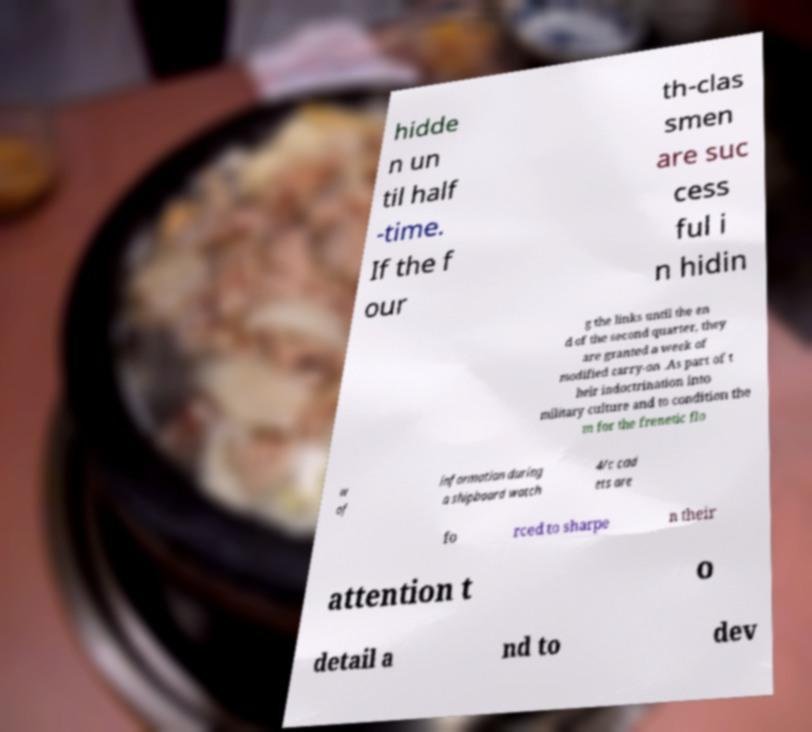Could you extract and type out the text from this image? hidde n un til half -time. If the f our th-clas smen are suc cess ful i n hidin g the links until the en d of the second quarter, they are granted a week of modified carry-on .As part of t heir indoctrination into military culture and to condition the m for the frenetic flo w of information during a shipboard watch 4/c cad ets are fo rced to sharpe n their attention t o detail a nd to dev 